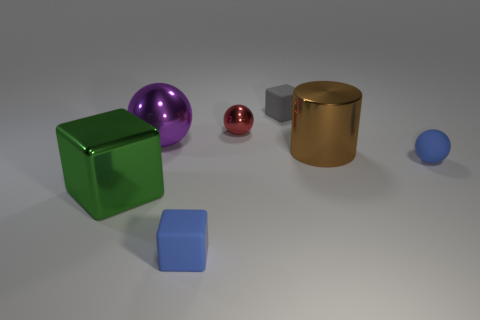There is a rubber block that is in front of the purple ball; is its color the same as the tiny rubber sphere?
Your answer should be very brief. Yes. Is there any other thing that is the same shape as the brown thing?
Keep it short and to the point. No. There is a tiny sphere that is right of the brown cylinder; is its color the same as the small matte block that is in front of the purple ball?
Keep it short and to the point. Yes. Are there any large blocks of the same color as the metallic cylinder?
Give a very brief answer. No. Is the material of the large brown thing right of the tiny gray cube the same as the small ball that is left of the gray matte thing?
Provide a succinct answer. Yes. There is a brown cylinder behind the small matte sphere; what is its size?
Your answer should be compact. Large. The green shiny cube has what size?
Provide a succinct answer. Large. There is a metallic thing in front of the blue rubber thing that is behind the matte thing that is in front of the big green cube; what is its size?
Your answer should be very brief. Large. Are there any large blue cubes made of the same material as the tiny gray object?
Make the answer very short. No. What is the shape of the brown metallic object?
Your answer should be compact. Cylinder. 